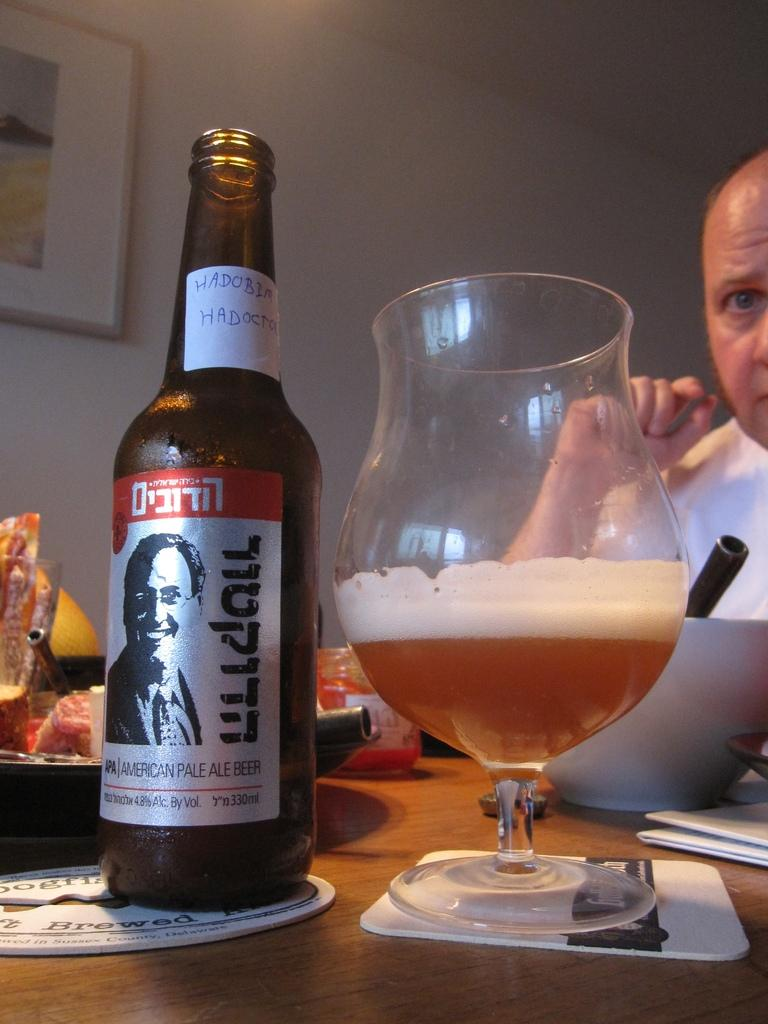<image>
Offer a succinct explanation of the picture presented. A man sitting at a table with a glass and a bottle of American pale ale. 